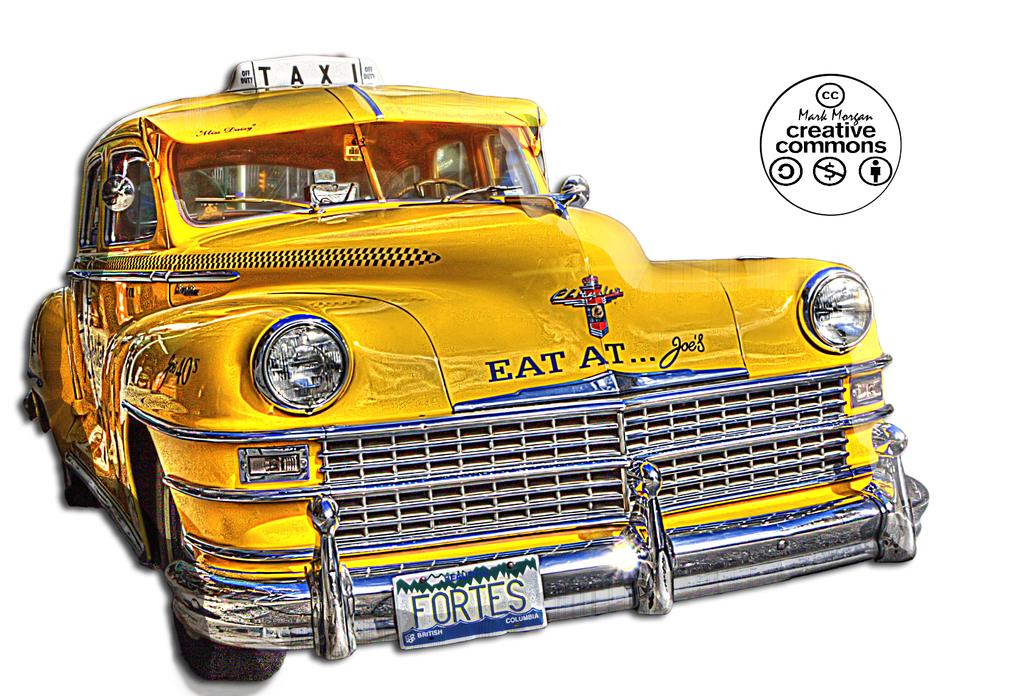<image>
Offer a succinct explanation of the picture presented. A yellow taxi that says eat at Joe's on the front bumper. 